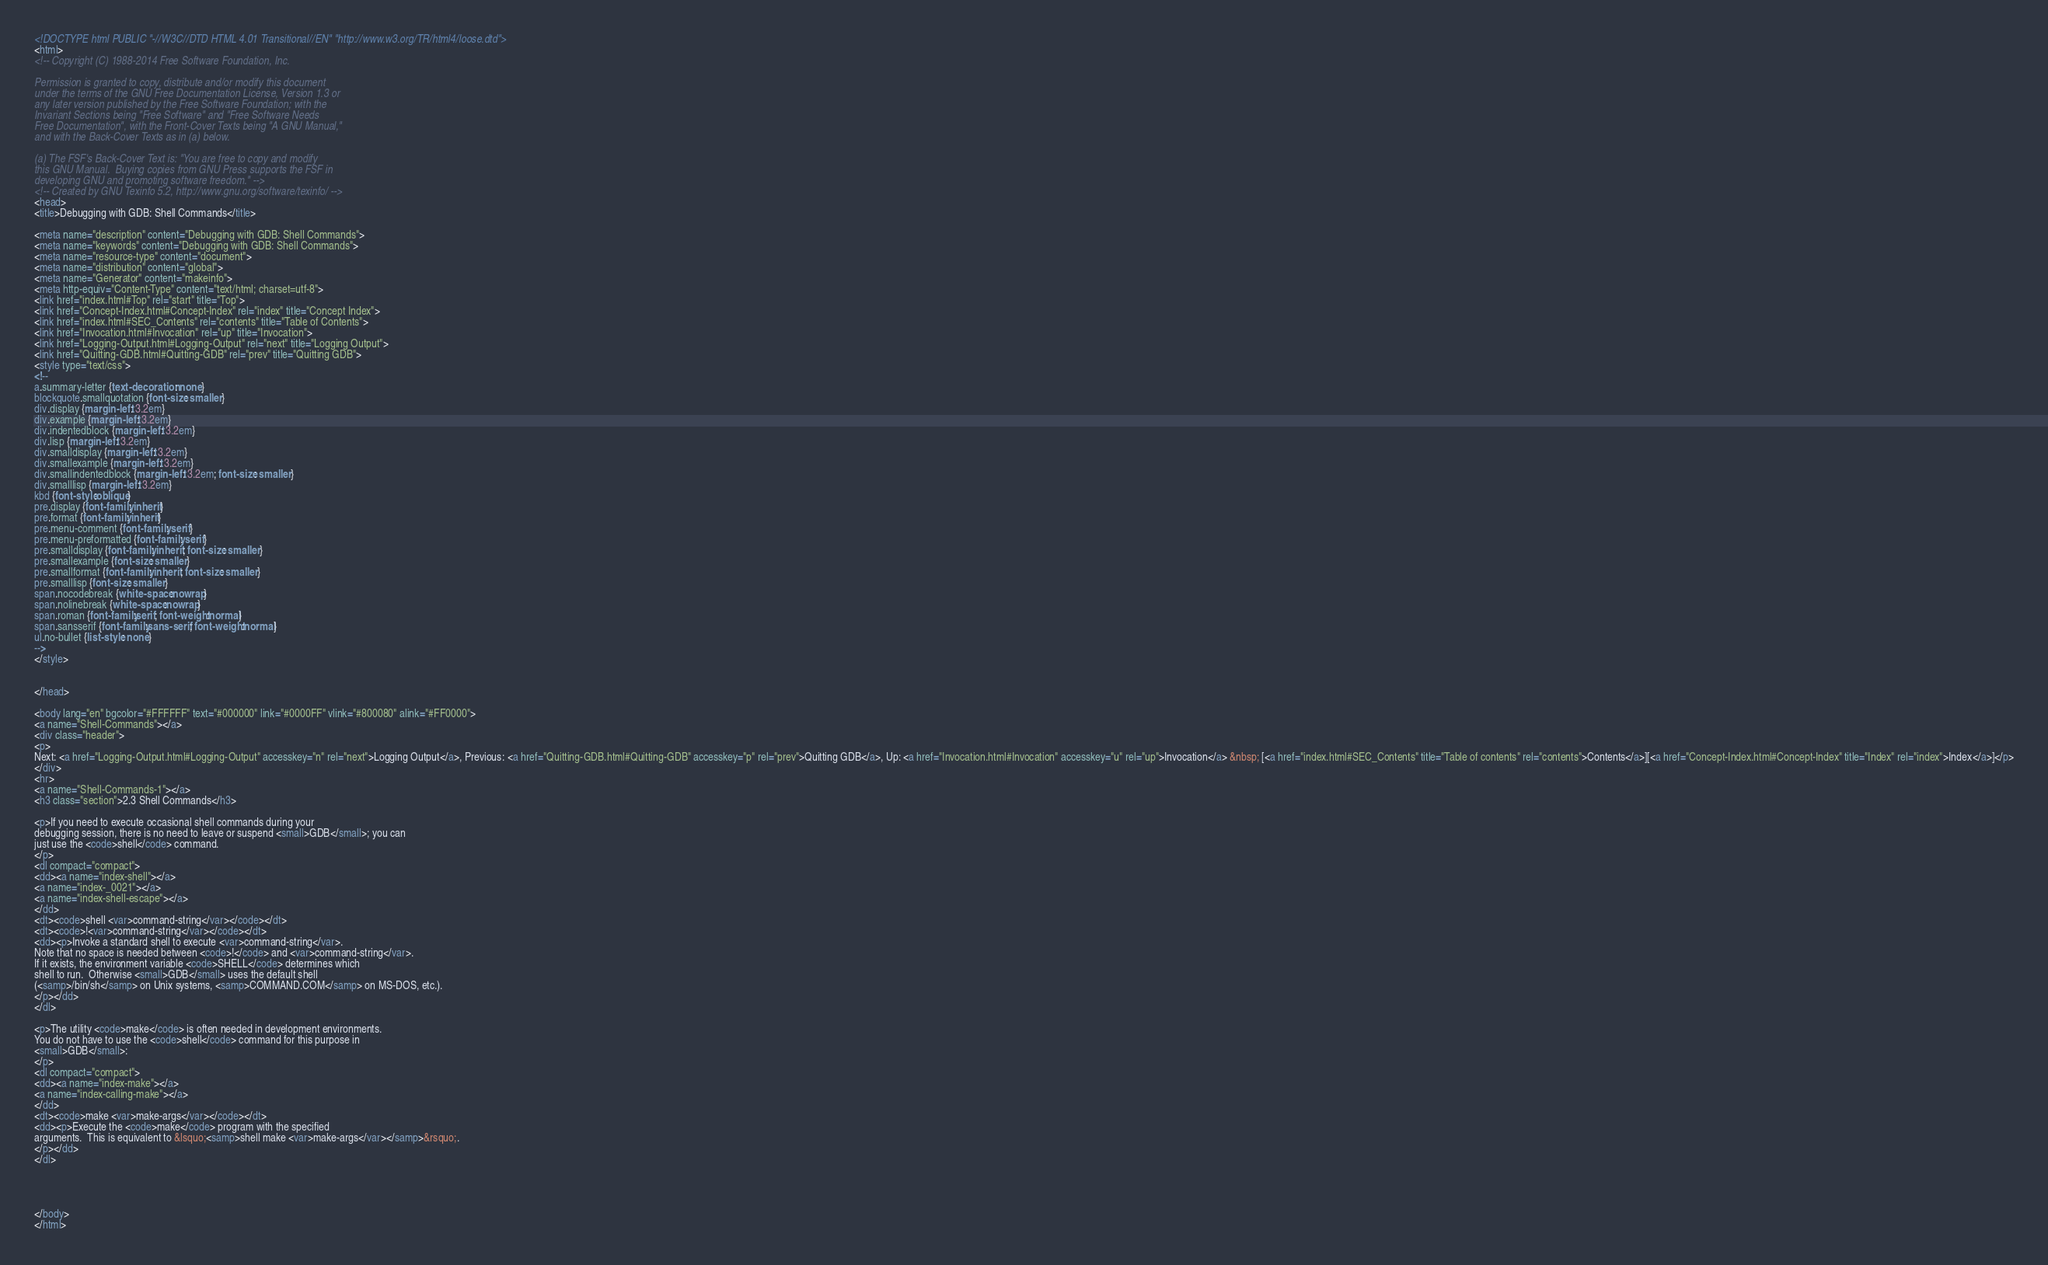Convert code to text. <code><loc_0><loc_0><loc_500><loc_500><_HTML_><!DOCTYPE html PUBLIC "-//W3C//DTD HTML 4.01 Transitional//EN" "http://www.w3.org/TR/html4/loose.dtd">
<html>
<!-- Copyright (C) 1988-2014 Free Software Foundation, Inc.

Permission is granted to copy, distribute and/or modify this document
under the terms of the GNU Free Documentation License, Version 1.3 or
any later version published by the Free Software Foundation; with the
Invariant Sections being "Free Software" and "Free Software Needs
Free Documentation", with the Front-Cover Texts being "A GNU Manual,"
and with the Back-Cover Texts as in (a) below.

(a) The FSF's Back-Cover Text is: "You are free to copy and modify
this GNU Manual.  Buying copies from GNU Press supports the FSF in
developing GNU and promoting software freedom." -->
<!-- Created by GNU Texinfo 5.2, http://www.gnu.org/software/texinfo/ -->
<head>
<title>Debugging with GDB: Shell Commands</title>

<meta name="description" content="Debugging with GDB: Shell Commands">
<meta name="keywords" content="Debugging with GDB: Shell Commands">
<meta name="resource-type" content="document">
<meta name="distribution" content="global">
<meta name="Generator" content="makeinfo">
<meta http-equiv="Content-Type" content="text/html; charset=utf-8">
<link href="index.html#Top" rel="start" title="Top">
<link href="Concept-Index.html#Concept-Index" rel="index" title="Concept Index">
<link href="index.html#SEC_Contents" rel="contents" title="Table of Contents">
<link href="Invocation.html#Invocation" rel="up" title="Invocation">
<link href="Logging-Output.html#Logging-Output" rel="next" title="Logging Output">
<link href="Quitting-GDB.html#Quitting-GDB" rel="prev" title="Quitting GDB">
<style type="text/css">
<!--
a.summary-letter {text-decoration: none}
blockquote.smallquotation {font-size: smaller}
div.display {margin-left: 3.2em}
div.example {margin-left: 3.2em}
div.indentedblock {margin-left: 3.2em}
div.lisp {margin-left: 3.2em}
div.smalldisplay {margin-left: 3.2em}
div.smallexample {margin-left: 3.2em}
div.smallindentedblock {margin-left: 3.2em; font-size: smaller}
div.smalllisp {margin-left: 3.2em}
kbd {font-style:oblique}
pre.display {font-family: inherit}
pre.format {font-family: inherit}
pre.menu-comment {font-family: serif}
pre.menu-preformatted {font-family: serif}
pre.smalldisplay {font-family: inherit; font-size: smaller}
pre.smallexample {font-size: smaller}
pre.smallformat {font-family: inherit; font-size: smaller}
pre.smalllisp {font-size: smaller}
span.nocodebreak {white-space:nowrap}
span.nolinebreak {white-space:nowrap}
span.roman {font-family:serif; font-weight:normal}
span.sansserif {font-family:sans-serif; font-weight:normal}
ul.no-bullet {list-style: none}
-->
</style>


</head>

<body lang="en" bgcolor="#FFFFFF" text="#000000" link="#0000FF" vlink="#800080" alink="#FF0000">
<a name="Shell-Commands"></a>
<div class="header">
<p>
Next: <a href="Logging-Output.html#Logging-Output" accesskey="n" rel="next">Logging Output</a>, Previous: <a href="Quitting-GDB.html#Quitting-GDB" accesskey="p" rel="prev">Quitting GDB</a>, Up: <a href="Invocation.html#Invocation" accesskey="u" rel="up">Invocation</a> &nbsp; [<a href="index.html#SEC_Contents" title="Table of contents" rel="contents">Contents</a>][<a href="Concept-Index.html#Concept-Index" title="Index" rel="index">Index</a>]</p>
</div>
<hr>
<a name="Shell-Commands-1"></a>
<h3 class="section">2.3 Shell Commands</h3>

<p>If you need to execute occasional shell commands during your
debugging session, there is no need to leave or suspend <small>GDB</small>; you can
just use the <code>shell</code> command.
</p>
<dl compact="compact">
<dd><a name="index-shell"></a>
<a name="index-_0021"></a>
<a name="index-shell-escape"></a>
</dd>
<dt><code>shell <var>command-string</var></code></dt>
<dt><code>!<var>command-string</var></code></dt>
<dd><p>Invoke a standard shell to execute <var>command-string</var>.
Note that no space is needed between <code>!</code> and <var>command-string</var>.
If it exists, the environment variable <code>SHELL</code> determines which
shell to run.  Otherwise <small>GDB</small> uses the default shell
(<samp>/bin/sh</samp> on Unix systems, <samp>COMMAND.COM</samp> on MS-DOS, etc.).
</p></dd>
</dl>

<p>The utility <code>make</code> is often needed in development environments.
You do not have to use the <code>shell</code> command for this purpose in
<small>GDB</small>:
</p>
<dl compact="compact">
<dd><a name="index-make"></a>
<a name="index-calling-make"></a>
</dd>
<dt><code>make <var>make-args</var></code></dt>
<dd><p>Execute the <code>make</code> program with the specified
arguments.  This is equivalent to &lsquo;<samp>shell make <var>make-args</var></samp>&rsquo;.
</p></dd>
</dl>




</body>
</html>
</code> 